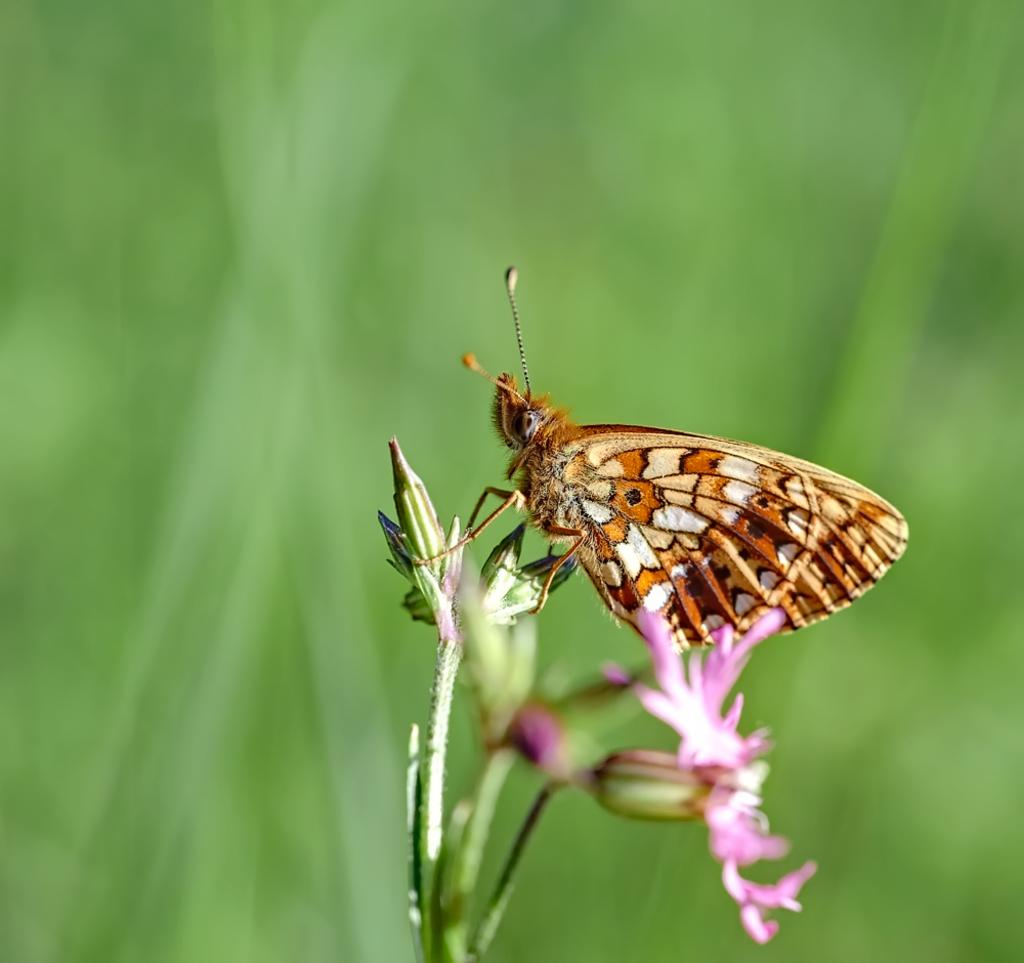What is the main subject of the image? There is a butterfly in the image. Where is the butterfly located in the image? The butterfly is sitting on flowers. Can you describe the background of the image? The background of the image is blurred. What type of pickle is visible in the image? There is no pickle present in the image. Can you describe the structure of the butterfly in the image? The provided facts do not include information about the butterfly's structure, so we cannot describe it. 